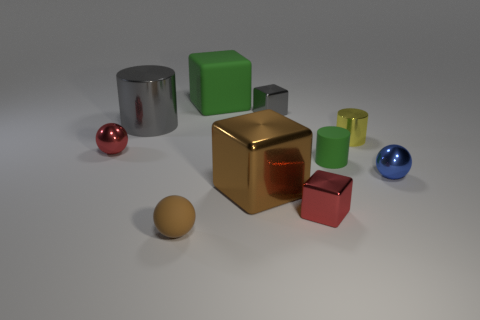What can you infer about the texture of the cube at the center? The central cube displays surfaces that seem to have a reflective and smooth texture, particularly on its top, which suggests a metallic finish, as opposed to the matte surfaces of some other objects. 